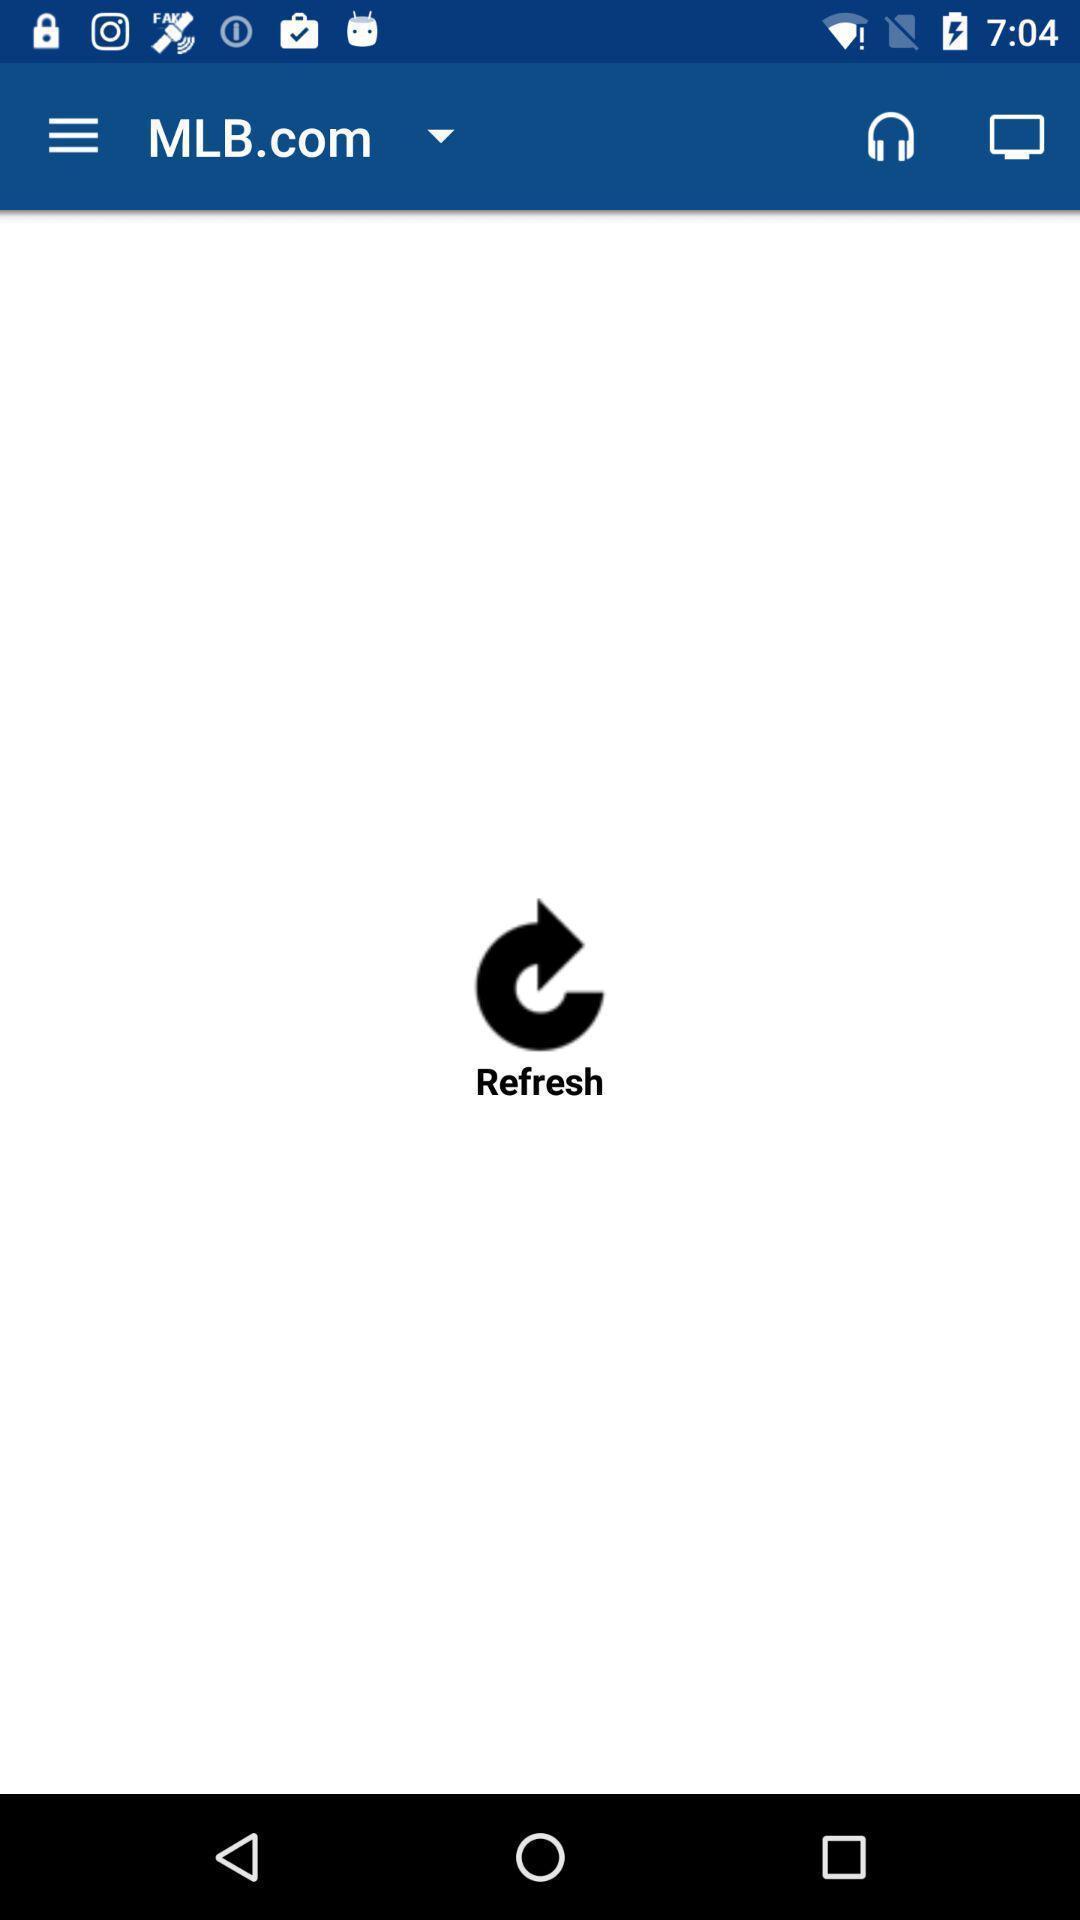Describe this image in words. Screen displays to refresh a page. 